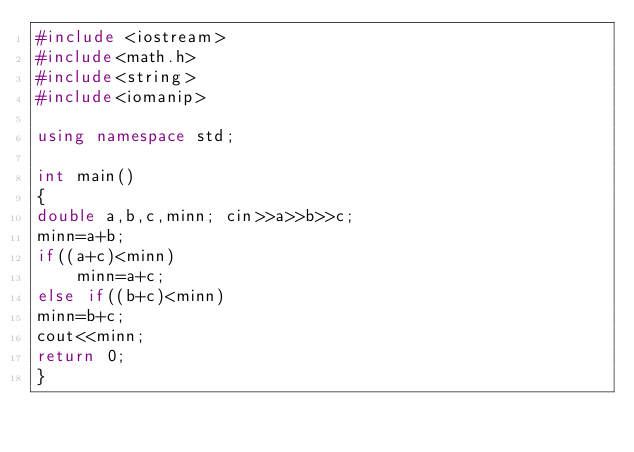<code> <loc_0><loc_0><loc_500><loc_500><_C++_>#include <iostream>
#include<math.h>
#include<string>
#include<iomanip>

using namespace std;

int main()
{
double a,b,c,minn; cin>>a>>b>>c;
minn=a+b;
if((a+c)<minn)
    minn=a+c;
else if((b+c)<minn)
minn=b+c;
cout<<minn;
return 0;
}
</code> 